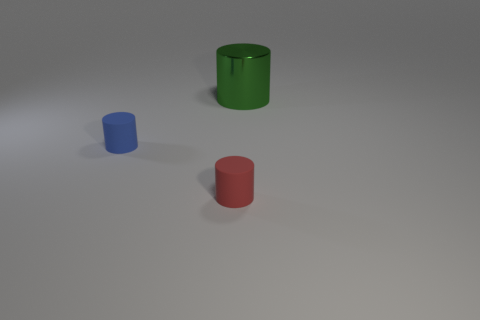The small thing that is on the right side of the small matte object left of the tiny red thing is what shape?
Your response must be concise. Cylinder. Are the small thing that is to the right of the blue matte object and the big object made of the same material?
Provide a short and direct response. No. How many blue objects are tiny matte cylinders or matte spheres?
Your response must be concise. 1. Are there any small matte things of the same color as the large metal thing?
Keep it short and to the point. No. Is there a purple block made of the same material as the small red object?
Provide a short and direct response. No. The thing that is both to the left of the big green object and behind the red rubber object has what shape?
Your answer should be very brief. Cylinder. What number of big objects are rubber objects or shiny things?
Provide a succinct answer. 1. What material is the large cylinder?
Give a very brief answer. Metal. The red matte cylinder has what size?
Provide a succinct answer. Small. There is a cylinder that is left of the large green metal cylinder and right of the blue matte object; what is its size?
Your answer should be compact. Small. 